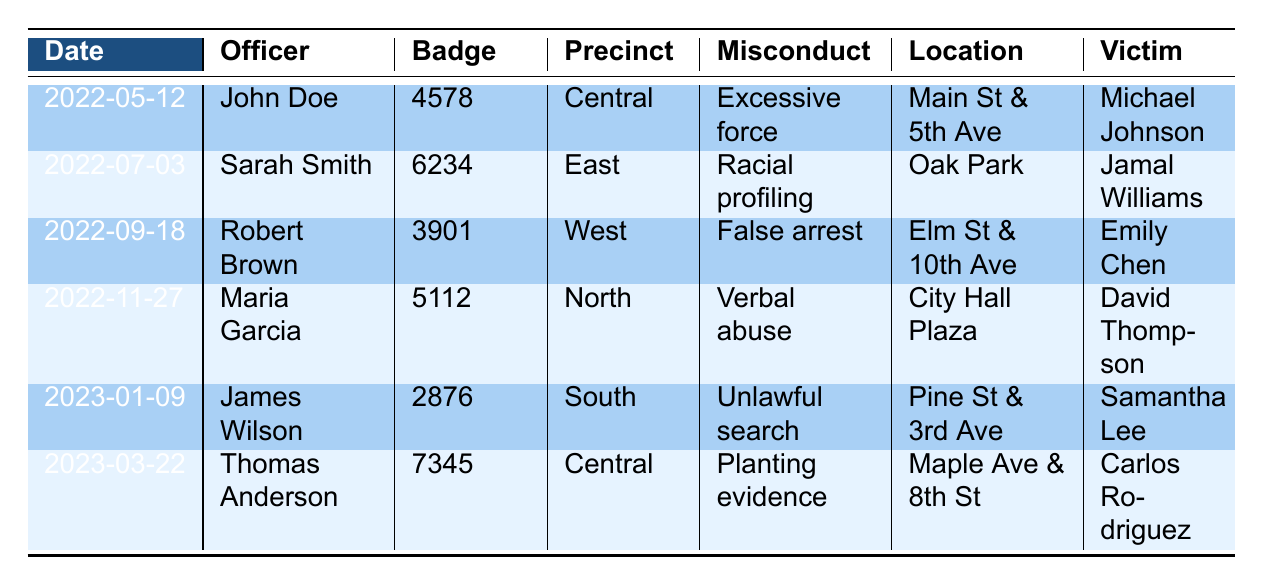What type of misconduct was reported by James Wilson? To find the type of misconduct reported by James Wilson, look for his name in the "Officer" column. He is listed with "Unlawful search" under the "Type of misconduct" column.
Answer: Unlawful search How many witness accounts were reported for the incident involving Maria Garcia? Look for Maria Garcia in the "Officer" column and check the corresponding "Witness count" column. It shows 5 witness accounts for her incident.
Answer: 5 Was there body cam footage for the incident involving Sarah Smith? Check the "Body cam footage" column for Sarah Smith's row. It indicates that there was no body cam footage for her incident.
Answer: No Which officer had the highest recorded witness count, and what was the misconduct type? Examine the "Witness count" column to find the maximum value, which is 5 corresponding to Maria Garcia. The misconduct type next to her name is "Verbal abuse."
Answer: Maria Garcia, Verbal abuse How many total incidents involved officers from the Central precinct? Count the occurrences of "Central" in the "Precinct" column. There are 2 incidents with officers from the Central precinct (John Doe and Thomas Anderson).
Answer: 2 What was the date of the incident involving planting evidence? Find "Planting evidence" in the "Type of misconduct" column, and look to the left in the same row to find the corresponding date, which is March 22, 2023.
Answer: 2023-03-22 Was a complaint filed in any incident where body cam footage was available? Review the rows with "Body cam footage" marked as true and see if the "Complaint filed" column also shows true. The incidents involving John Doe, Robert Brown, and Thomas Anderson show that complaints were filed.
Answer: Yes Which officer had misconduct involving racial profiling? Look for "Racial profiling" in the "Type of misconduct" column. Sarah Smith is the officer associated with this misconduct.
Answer: Sarah Smith How many officers had incidents where no complaint was filed? Go through the "Complaint filed" column and count the number of entries marked as false. There is 1 incident involving Maria Garcia where no complaint was filed.
Answer: 1 What is the total number of misconduct incidents recorded? Count the total number of rows in the table, which presents each incident. There are 6 recorded incidents of police misconduct.
Answer: 6 How many officers from the North precinct were involved in misconduct? Count the occurrences of "North" in the "Precinct" column. Maria Garcia was the only officer from the North precinct involved in misconduct.
Answer: 1 